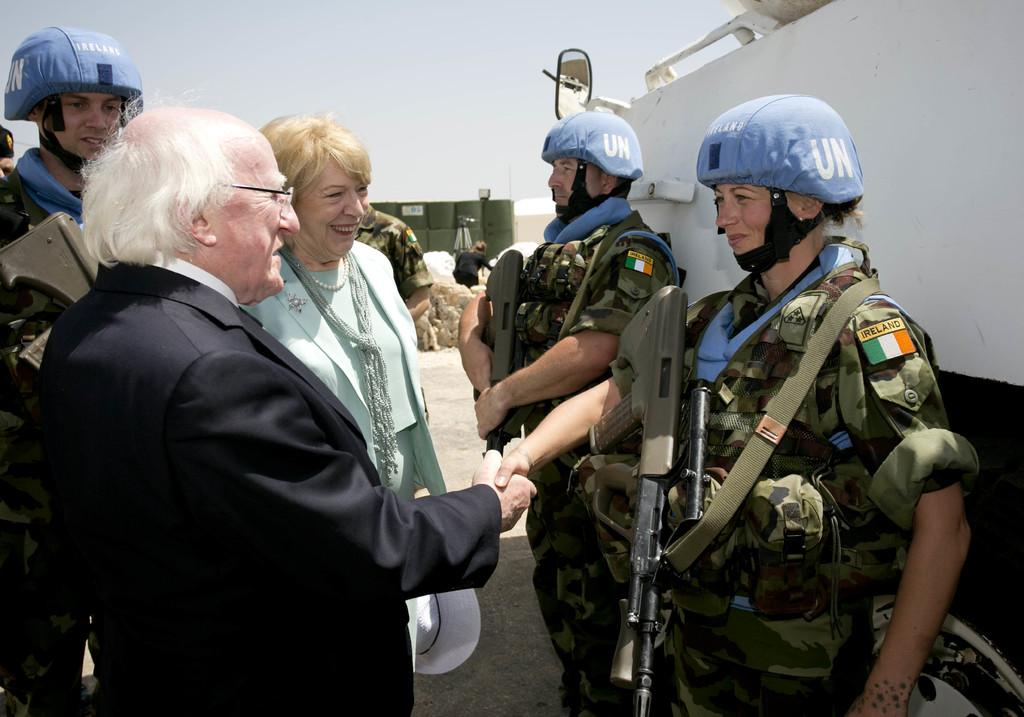How many people are in the image? There is a group of people in the image, but the exact number is not specified. What are the people doing in the image? The people are standing on the ground. What can be seen in the background of the image? The sky is visible in the background of the image. What type of paper is being smashed by the monkey in the image? There is no monkey or paper present in the image. How does the monkey interact with the paper in the image? There is no monkey or paper present in the image, so it is not possible to describe any interaction between them. 